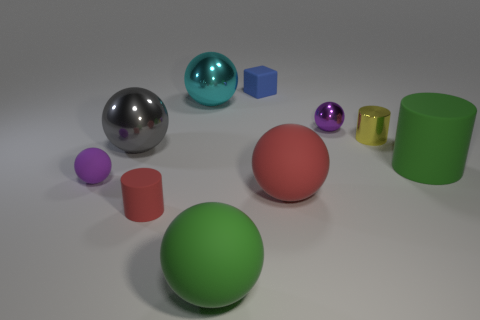What is the size of the thing that is the same color as the small matte ball?
Provide a succinct answer. Small. Is the number of gray metallic spheres that are on the right side of the shiny cylinder greater than the number of blue shiny cylinders?
Make the answer very short. No. Does the big cyan metal thing have the same shape as the small object that is behind the large cyan metallic ball?
Provide a succinct answer. No. Is there a big green metal ball?
Your answer should be very brief. No. What number of large things are either gray spheres or green objects?
Provide a short and direct response. 3. Is the number of spheres behind the tiny yellow object greater than the number of small matte blocks that are to the left of the small red thing?
Offer a terse response. Yes. Do the small red thing and the big thing that is behind the purple metal object have the same material?
Make the answer very short. No. What color is the tiny rubber cube?
Provide a succinct answer. Blue. There is a tiny matte thing left of the gray sphere; what shape is it?
Your answer should be compact. Sphere. What number of purple objects are tiny things or large cylinders?
Ensure brevity in your answer.  2. 